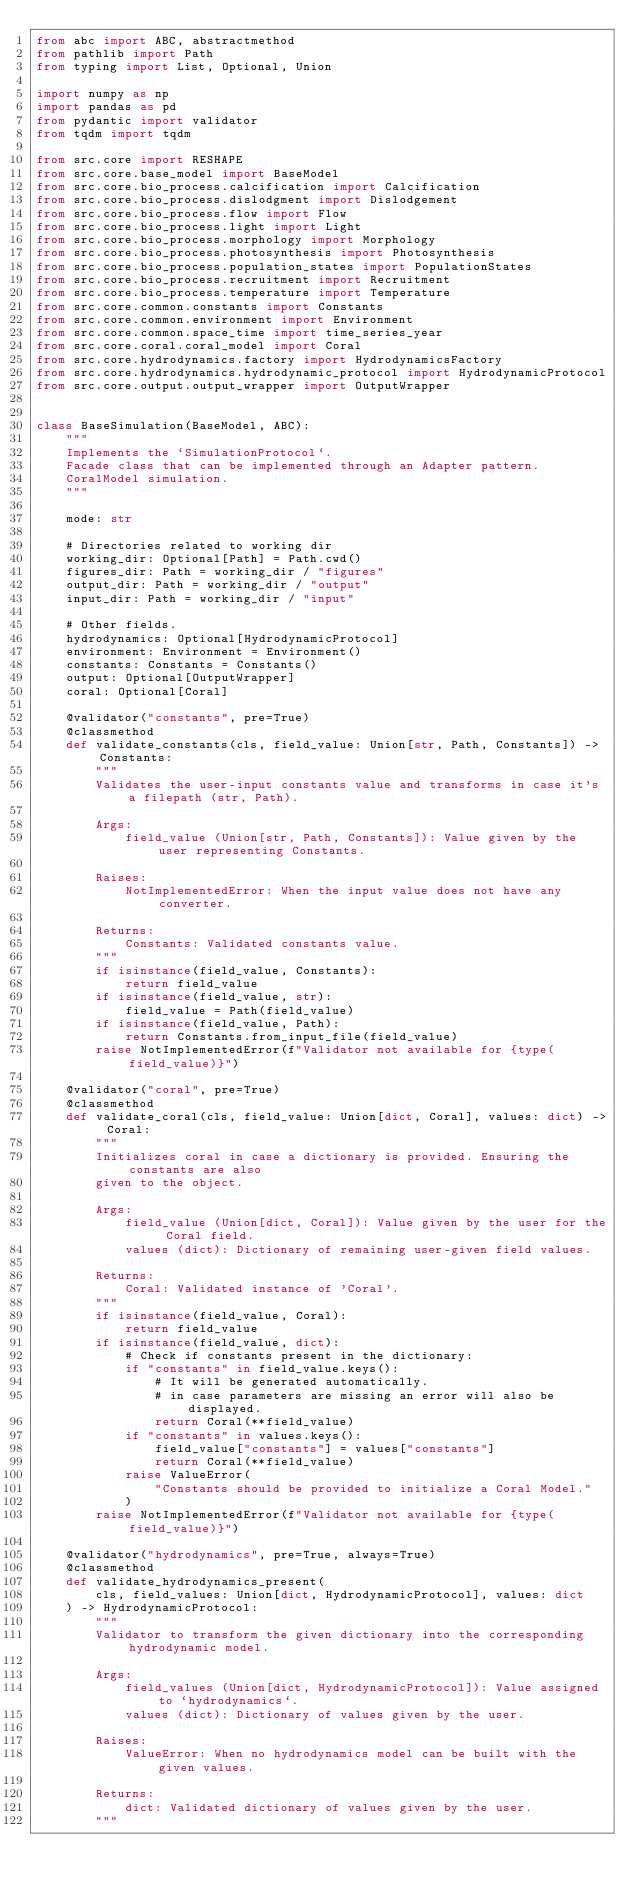<code> <loc_0><loc_0><loc_500><loc_500><_Python_>from abc import ABC, abstractmethod
from pathlib import Path
from typing import List, Optional, Union

import numpy as np
import pandas as pd
from pydantic import validator
from tqdm import tqdm

from src.core import RESHAPE
from src.core.base_model import BaseModel
from src.core.bio_process.calcification import Calcification
from src.core.bio_process.dislodgment import Dislodgement
from src.core.bio_process.flow import Flow
from src.core.bio_process.light import Light
from src.core.bio_process.morphology import Morphology
from src.core.bio_process.photosynthesis import Photosynthesis
from src.core.bio_process.population_states import PopulationStates
from src.core.bio_process.recruitment import Recruitment
from src.core.bio_process.temperature import Temperature
from src.core.common.constants import Constants
from src.core.common.environment import Environment
from src.core.common.space_time import time_series_year
from src.core.coral.coral_model import Coral
from src.core.hydrodynamics.factory import HydrodynamicsFactory
from src.core.hydrodynamics.hydrodynamic_protocol import HydrodynamicProtocol
from src.core.output.output_wrapper import OutputWrapper


class BaseSimulation(BaseModel, ABC):
    """
    Implements the `SimulationProtocol`.
    Facade class that can be implemented through an Adapter pattern.
    CoralModel simulation.
    """

    mode: str

    # Directories related to working dir
    working_dir: Optional[Path] = Path.cwd()
    figures_dir: Path = working_dir / "figures"
    output_dir: Path = working_dir / "output"
    input_dir: Path = working_dir / "input"

    # Other fields.
    hydrodynamics: Optional[HydrodynamicProtocol]
    environment: Environment = Environment()
    constants: Constants = Constants()
    output: Optional[OutputWrapper]
    coral: Optional[Coral]

    @validator("constants", pre=True)
    @classmethod
    def validate_constants(cls, field_value: Union[str, Path, Constants]) -> Constants:
        """
        Validates the user-input constants value and transforms in case it's a filepath (str, Path).

        Args:
            field_value (Union[str, Path, Constants]): Value given by the user representing Constants.

        Raises:
            NotImplementedError: When the input value does not have any converter.

        Returns:
            Constants: Validated constants value.
        """
        if isinstance(field_value, Constants):
            return field_value
        if isinstance(field_value, str):
            field_value = Path(field_value)
        if isinstance(field_value, Path):
            return Constants.from_input_file(field_value)
        raise NotImplementedError(f"Validator not available for {type(field_value)}")

    @validator("coral", pre=True)
    @classmethod
    def validate_coral(cls, field_value: Union[dict, Coral], values: dict) -> Coral:
        """
        Initializes coral in case a dictionary is provided. Ensuring the constants are also
        given to the object.

        Args:
            field_value (Union[dict, Coral]): Value given by the user for the Coral field.
            values (dict): Dictionary of remaining user-given field values.

        Returns:
            Coral: Validated instance of 'Coral'.
        """
        if isinstance(field_value, Coral):
            return field_value
        if isinstance(field_value, dict):
            # Check if constants present in the dictionary:
            if "constants" in field_value.keys():
                # It will be generated automatically.
                # in case parameters are missing an error will also be displayed.
                return Coral(**field_value)
            if "constants" in values.keys():
                field_value["constants"] = values["constants"]
                return Coral(**field_value)
            raise ValueError(
                "Constants should be provided to initialize a Coral Model."
            )
        raise NotImplementedError(f"Validator not available for {type(field_value)}")

    @validator("hydrodynamics", pre=True, always=True)
    @classmethod
    def validate_hydrodynamics_present(
        cls, field_values: Union[dict, HydrodynamicProtocol], values: dict
    ) -> HydrodynamicProtocol:
        """
        Validator to transform the given dictionary into the corresponding hydrodynamic model.

        Args:
            field_values (Union[dict, HydrodynamicProtocol]): Value assigned to `hydrodynamics`.
            values (dict): Dictionary of values given by the user.

        Raises:
            ValueError: When no hydrodynamics model can be built with the given values.

        Returns:
            dict: Validated dictionary of values given by the user.
        """</code> 